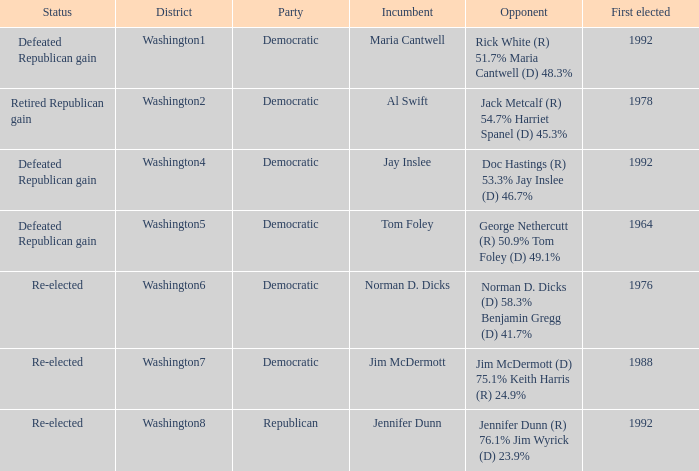What was the result of the election of doc hastings (r) 53.3% jay inslee (d) 46.7% Defeated Republican gain. 